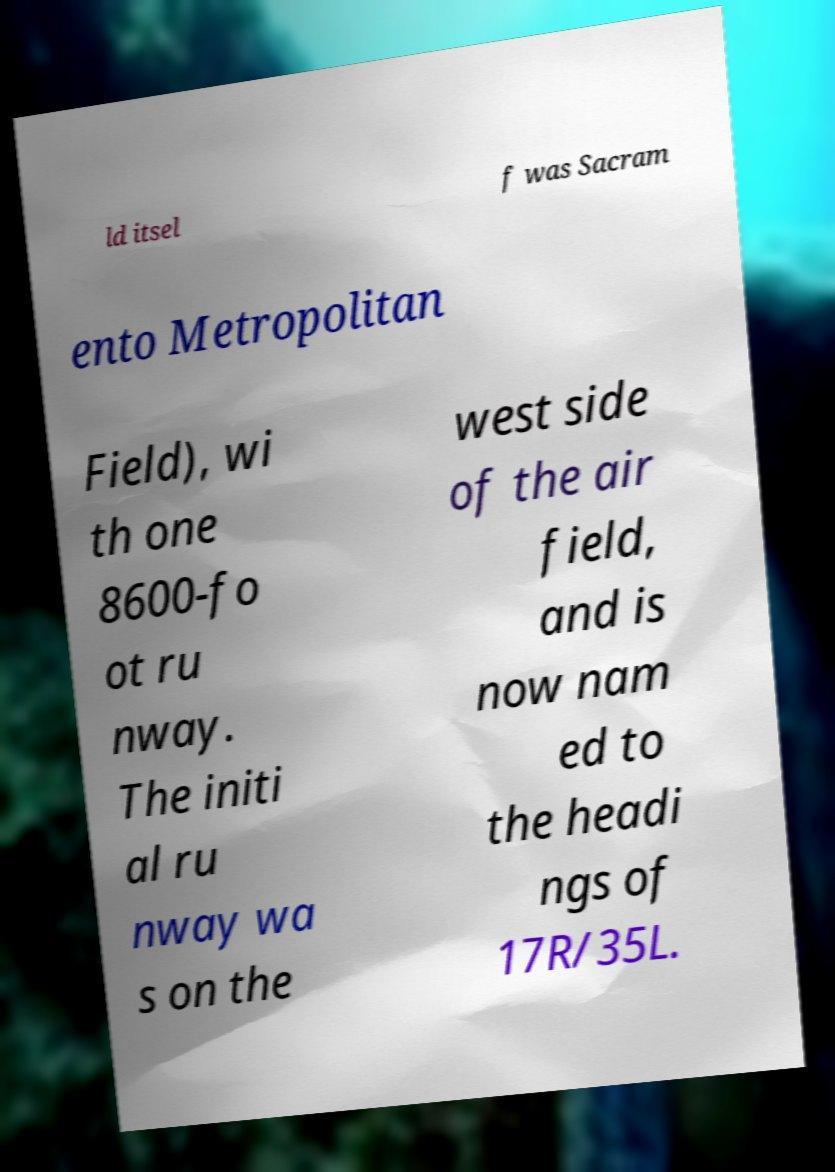Please read and relay the text visible in this image. What does it say? ld itsel f was Sacram ento Metropolitan Field), wi th one 8600-fo ot ru nway. The initi al ru nway wa s on the west side of the air field, and is now nam ed to the headi ngs of 17R/35L. 